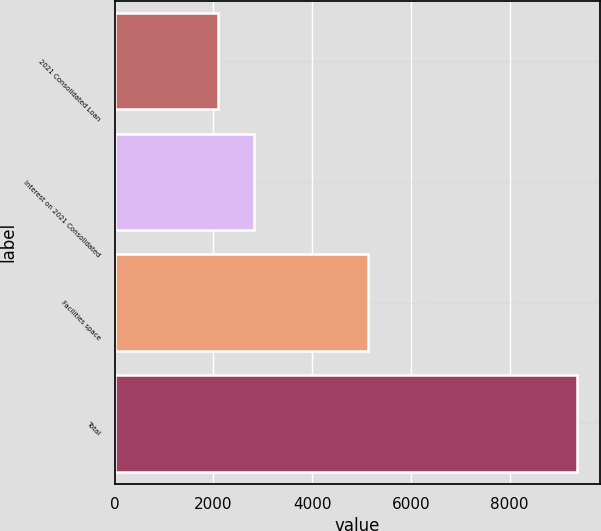Convert chart. <chart><loc_0><loc_0><loc_500><loc_500><bar_chart><fcel>2021 Consolidated Loan<fcel>Interest on 2021 Consolidated<fcel>Facilities space<fcel>Total<nl><fcel>2102<fcel>2828.1<fcel>5131<fcel>9363<nl></chart> 